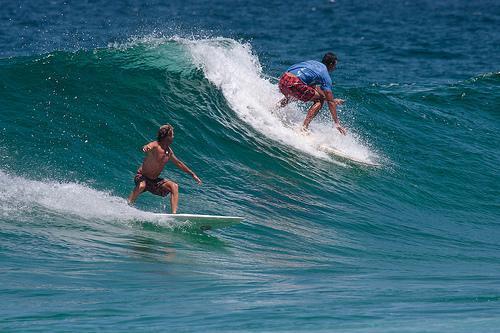How many men are there?
Give a very brief answer. 2. 